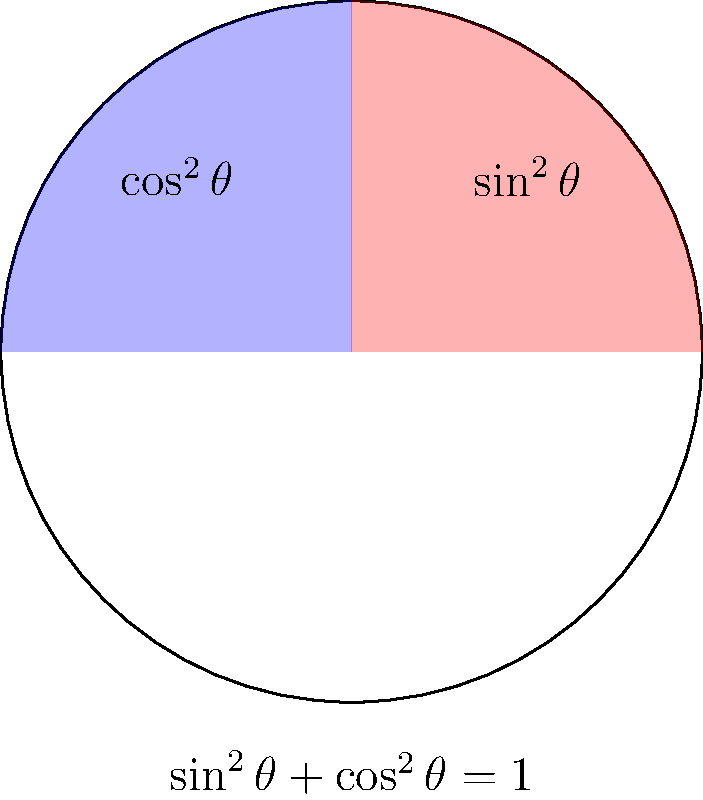In the unit circle diagram above, the red region represents $\sin^2\theta$ and the blue region represents $\cos^2\theta$. What trigonometric identity is visually demonstrated by this color-coded representation? To understand the trigonometric identity demonstrated in this diagram, let's follow these steps:

1. Observe that the entire circle is divided into four quadrants.

2. The red region (labeled $\sin^2\theta$) occupies the first quadrant.

3. The blue region (labeled $\cos^2\theta$) occupies the second quadrant.

4. Together, the red and blue regions cover exactly half of the circle.

5. In a unit circle, the total area is $\pi r^2 = \pi (1)^2 = \pi$.

6. The area of half a circle is $\frac{1}{2}\pi$.

7. Since the red and blue regions together make up half the circle, we can conclude:
   Area of red region + Area of blue region = $\frac{1}{2}\pi$

8. In terms of the functions represented:
   $\sin^2\theta + \cos^2\theta = \frac{1}{2}\pi \div \pi = 1$

9. This visually demonstrates the fundamental trigonometric identity:
   $\sin^2\theta + \cos^2\theta = 1$

This identity is also stated at the bottom of the diagram for clarity.
Answer: $\sin^2\theta + \cos^2\theta = 1$ 